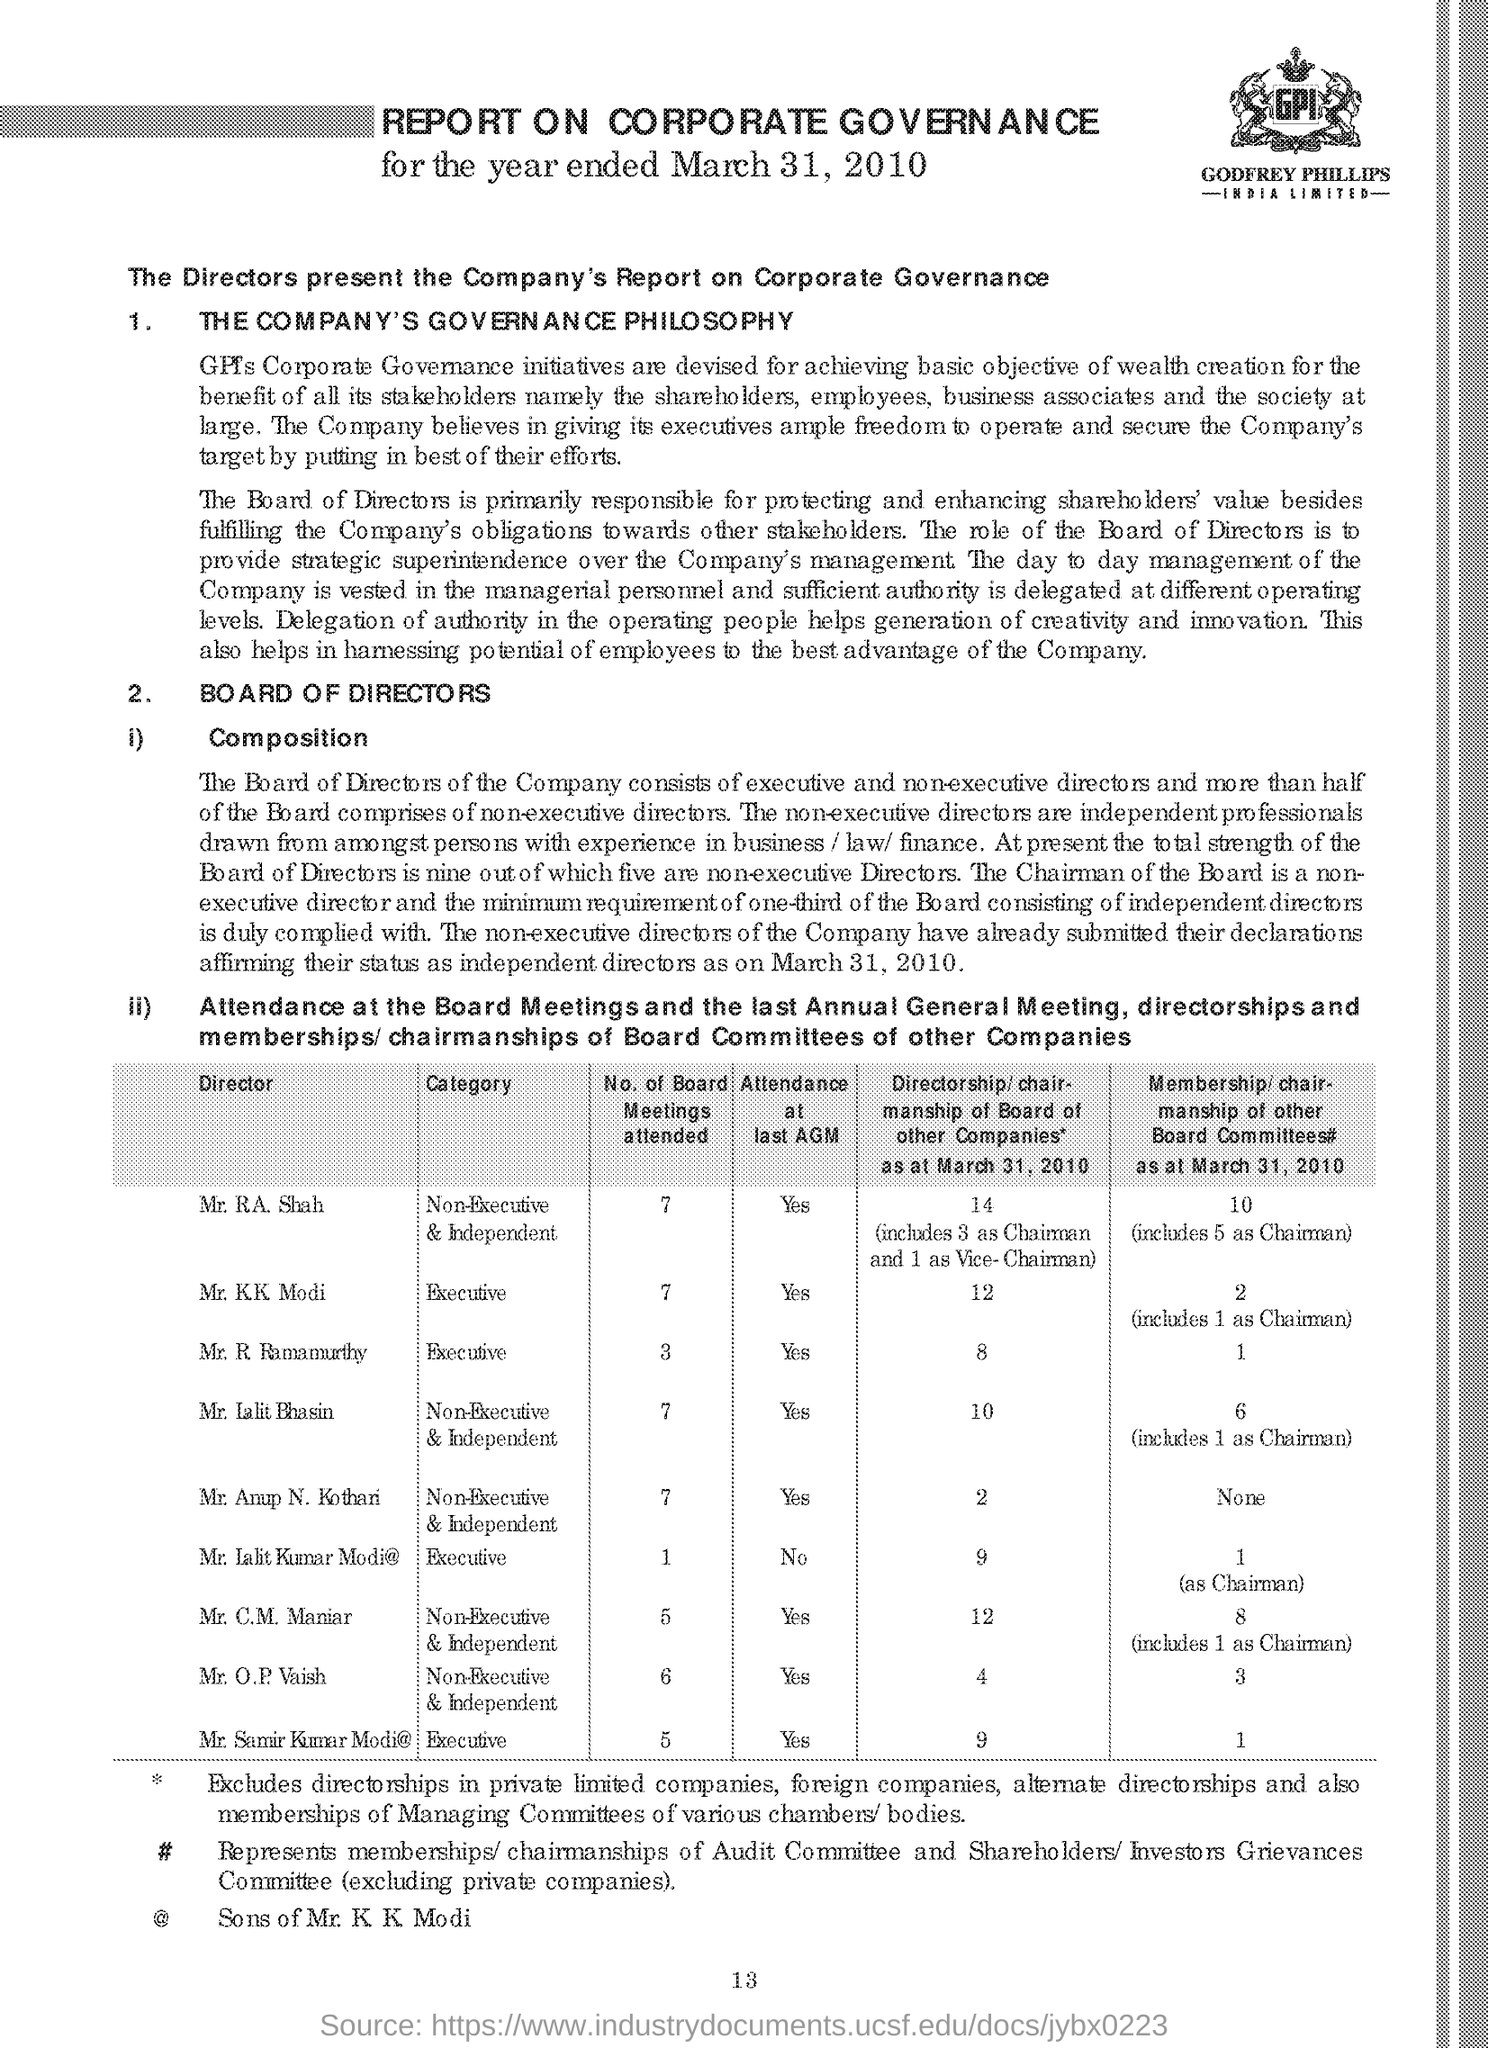Identify some key points in this picture. The directors present the company's report on corporate governance. 